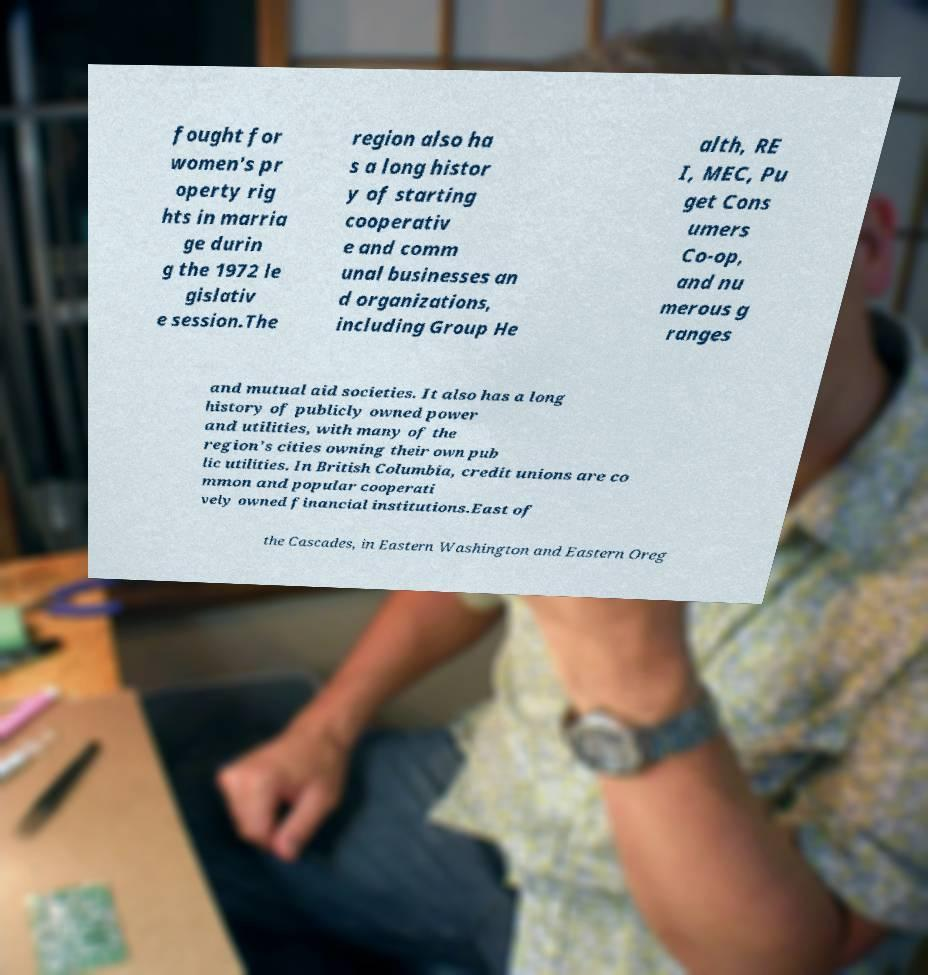Could you extract and type out the text from this image? fought for women's pr operty rig hts in marria ge durin g the 1972 le gislativ e session.The region also ha s a long histor y of starting cooperativ e and comm unal businesses an d organizations, including Group He alth, RE I, MEC, Pu get Cons umers Co-op, and nu merous g ranges and mutual aid societies. It also has a long history of publicly owned power and utilities, with many of the region's cities owning their own pub lic utilities. In British Columbia, credit unions are co mmon and popular cooperati vely owned financial institutions.East of the Cascades, in Eastern Washington and Eastern Oreg 